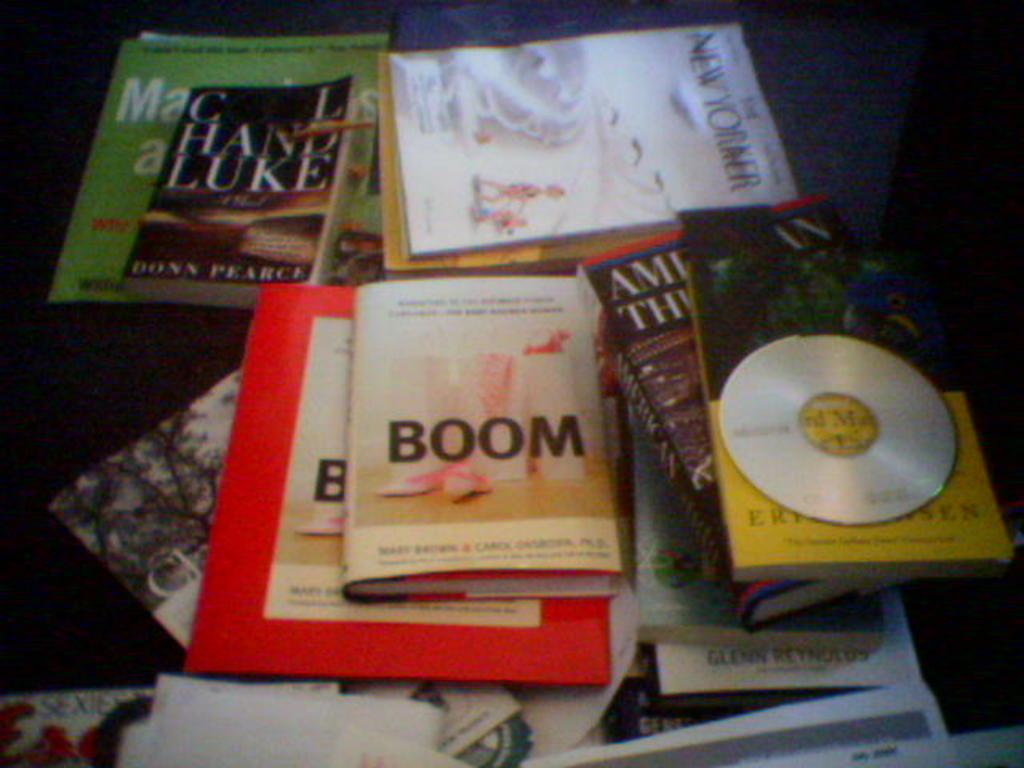<image>
Give a short and clear explanation of the subsequent image. A stack of books and magazines including Boom and the New Yorker. 